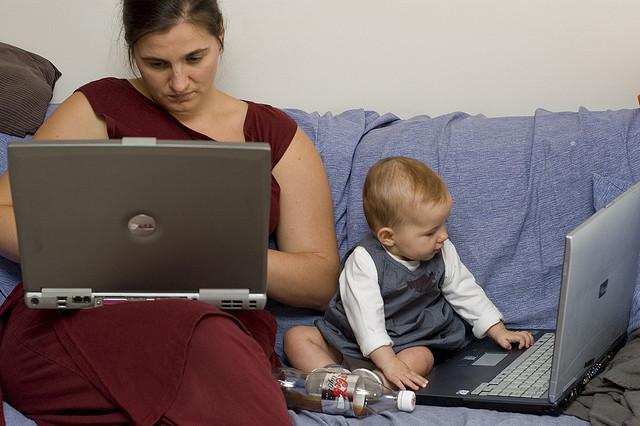Who was drinking from the coke bottle? Please explain your reasoning. woman. The woman on the laptop was drinking from the coke bottle and now it is empty. 